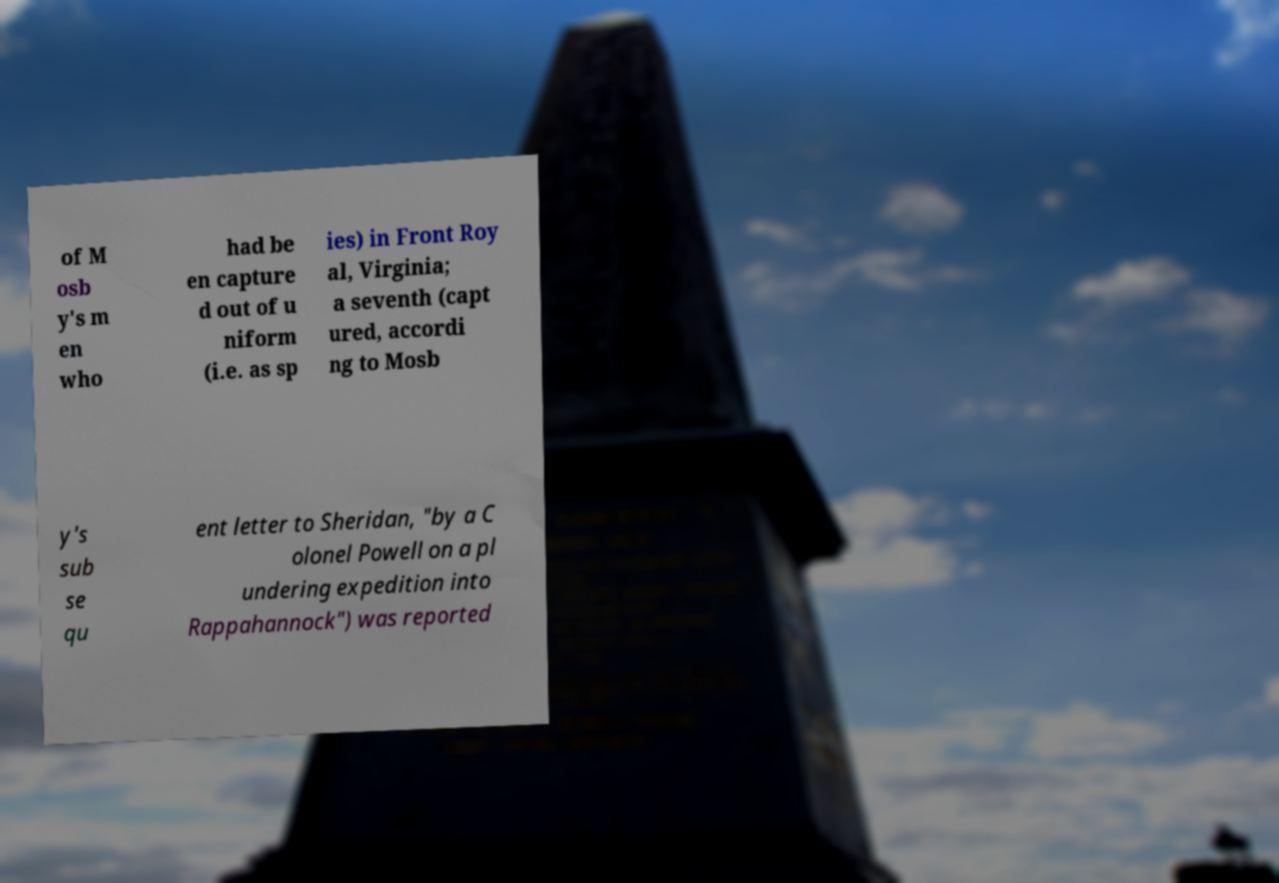What messages or text are displayed in this image? I need them in a readable, typed format. of M osb y's m en who had be en capture d out of u niform (i.e. as sp ies) in Front Roy al, Virginia; a seventh (capt ured, accordi ng to Mosb y's sub se qu ent letter to Sheridan, "by a C olonel Powell on a pl undering expedition into Rappahannock") was reported 